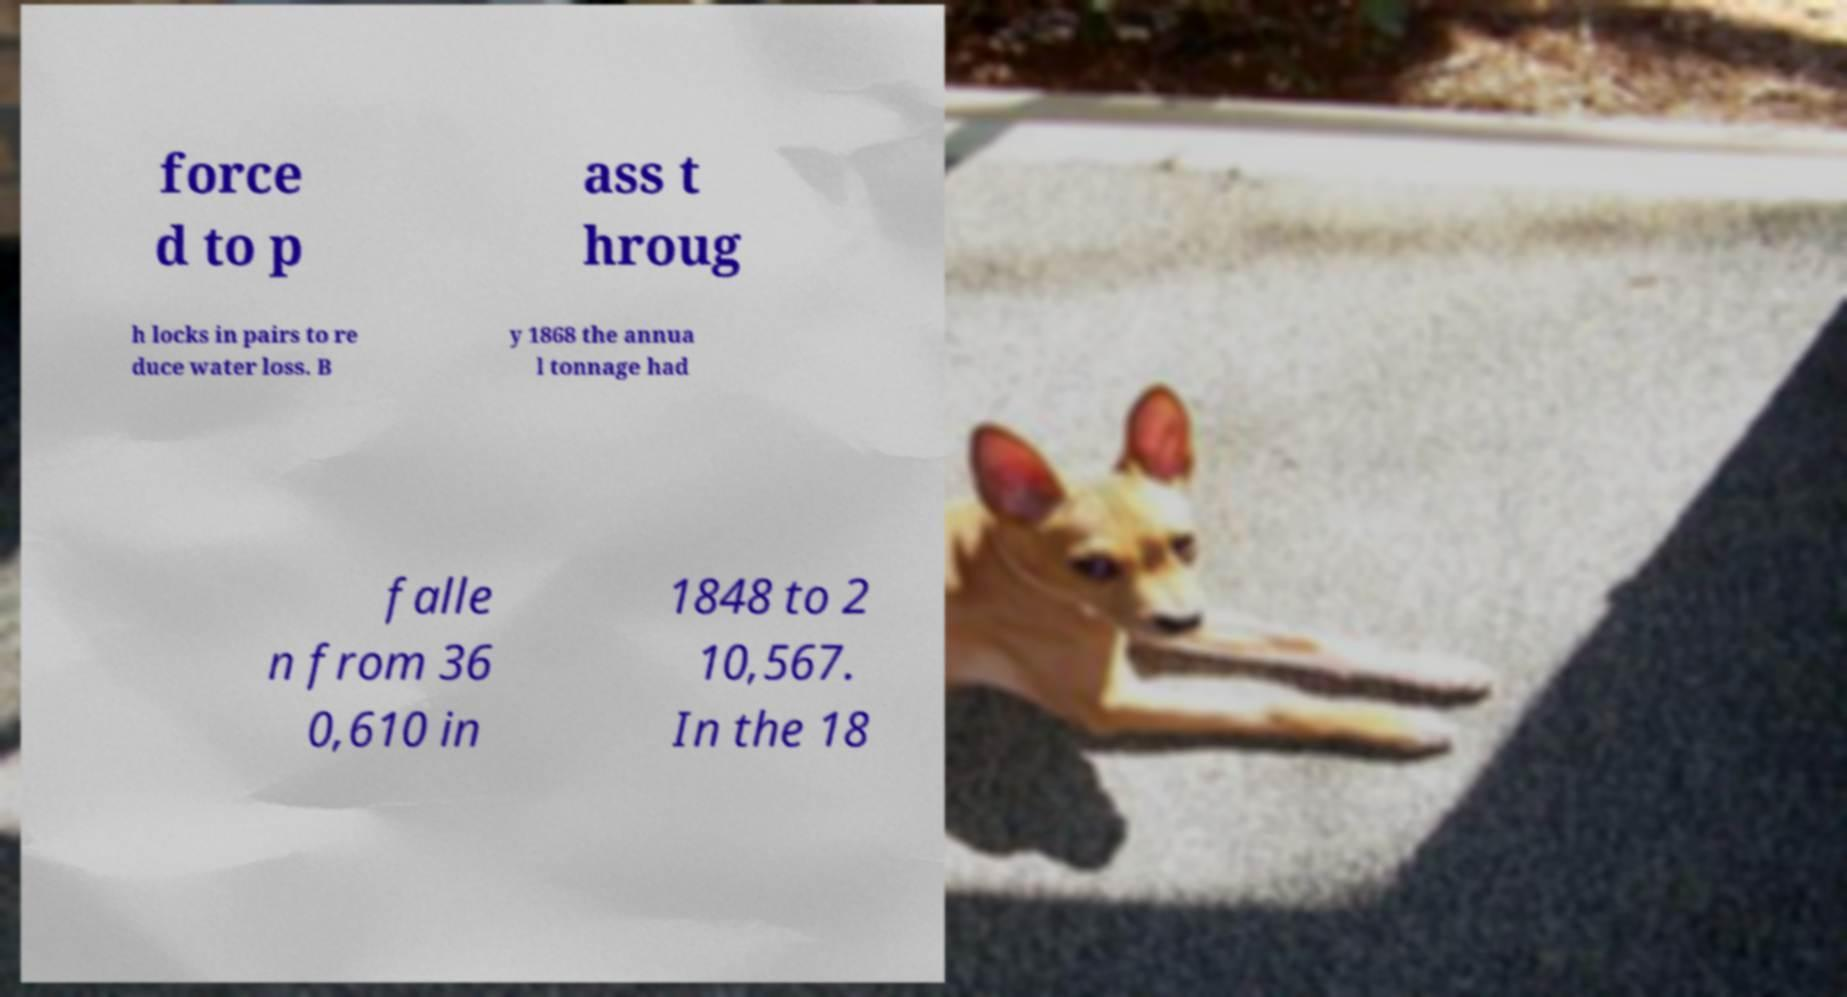Can you accurately transcribe the text from the provided image for me? force d to p ass t hroug h locks in pairs to re duce water loss. B y 1868 the annua l tonnage had falle n from 36 0,610 in 1848 to 2 10,567. In the 18 